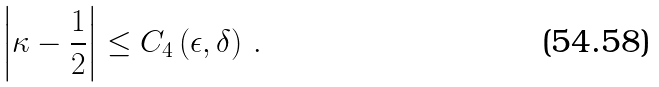<formula> <loc_0><loc_0><loc_500><loc_500>\left | \kappa - \frac { 1 } { 2 } \right | \leq C _ { 4 } \left ( \epsilon , \delta \right ) \, .</formula> 